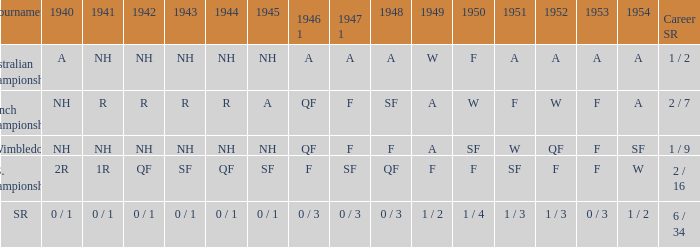What is the contest that had a conclusion of a in 1954 and nh in 1942? Australian Championships. 